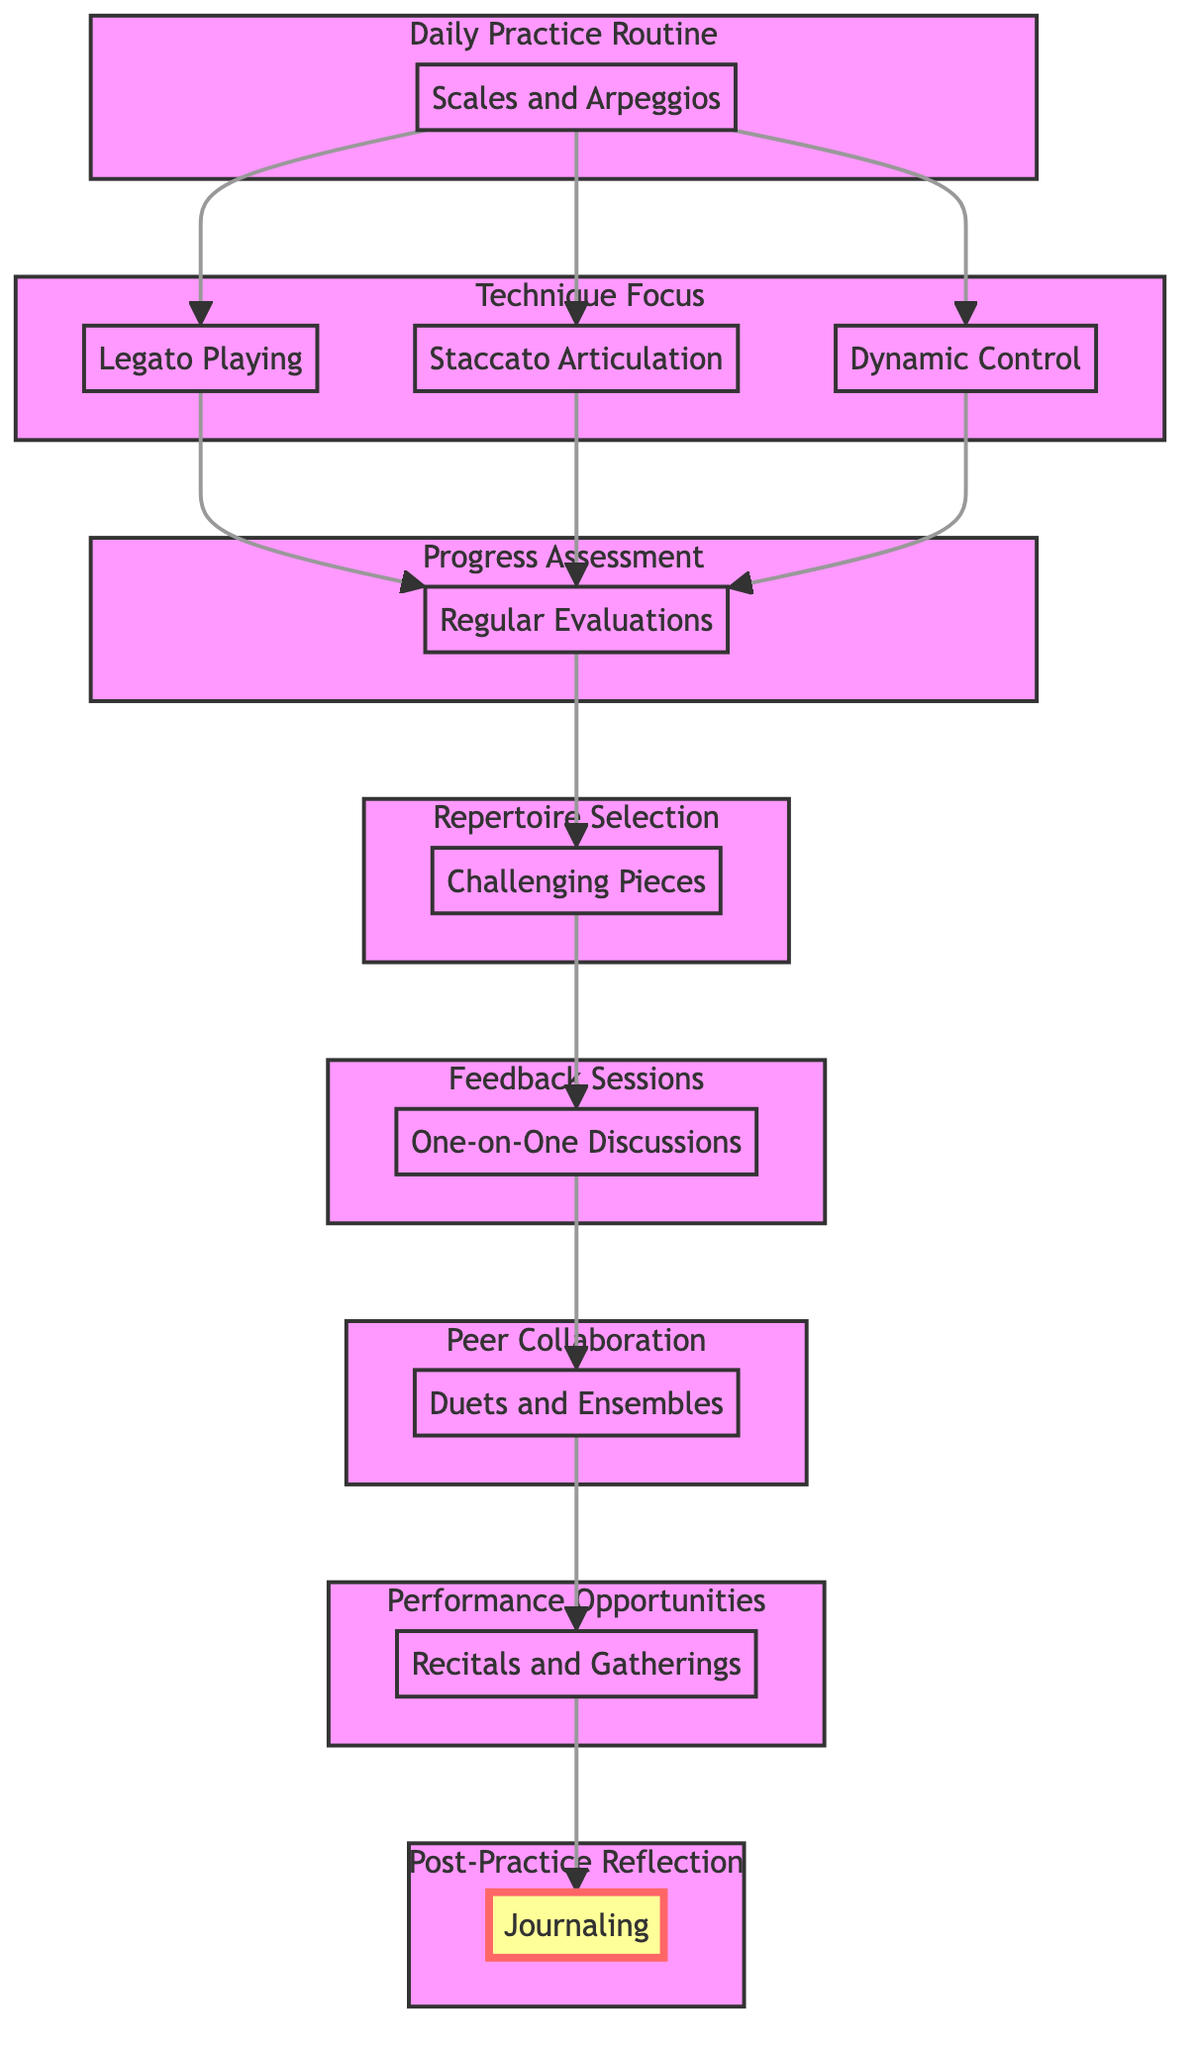What is the first step in the flow chart? The first step in the flow chart is "Daily Practice Routine," which establishes the foundation for the entire process.
Answer: Daily Practice Routine How many techniques are mentioned in the Technique Focus section? The Technique Focus section lists three specific techniques: Legato Playing, Staccato Articulation, and Dynamic Control, indicating that there are three techniques in total.
Answer: Three Which element follows "Progress Assessment"? After "Progress Assessment," the next element in the flow is "Repertoire Selection," showing how assessment leads to selecting appropriate pieces for further development.
Answer: Repertoire Selection What is the purpose of "Feedback Sessions"? The purpose of "Feedback Sessions" is to provide constructive feedback and encouragement, which is crucial for a student's growth and improvement.
Answer: Constructive feedback and encouragement Which section comes after "Peer Collaboration"? "Performance Opportunities" comes after "Peer Collaboration," reflecting the progression from practicing with peers to public performance settings.
Answer: Performance Opportunities How many elements are involved in the flow from "Daily Practice Routine" to "Post-Practice Reflection"? The flow includes a total of seven elements: Daily Practice Routine, Technique Focus, Progress Assessment, Repertoire Selection, Feedback Sessions, Peer Collaboration, and Performance Opportunities, culminating in Post-Practice Reflection.
Answer: Seven What is the relationship between "Reflective Journaling" and the overall practice process? "Post-Practice Reflection" through journaling serves as the concluding step, promoting self-awareness and reinforcing lessons learned during practice, thus impacting the overall process positively.
Answer: Self-awareness What is the main role of "Performance Opportunities"? The main role of "Performance Opportunities" is to build confidence and performance skills in the student, ultimately completing the cycle of learning and development in piano techniques.
Answer: Build confidence and performance skills 